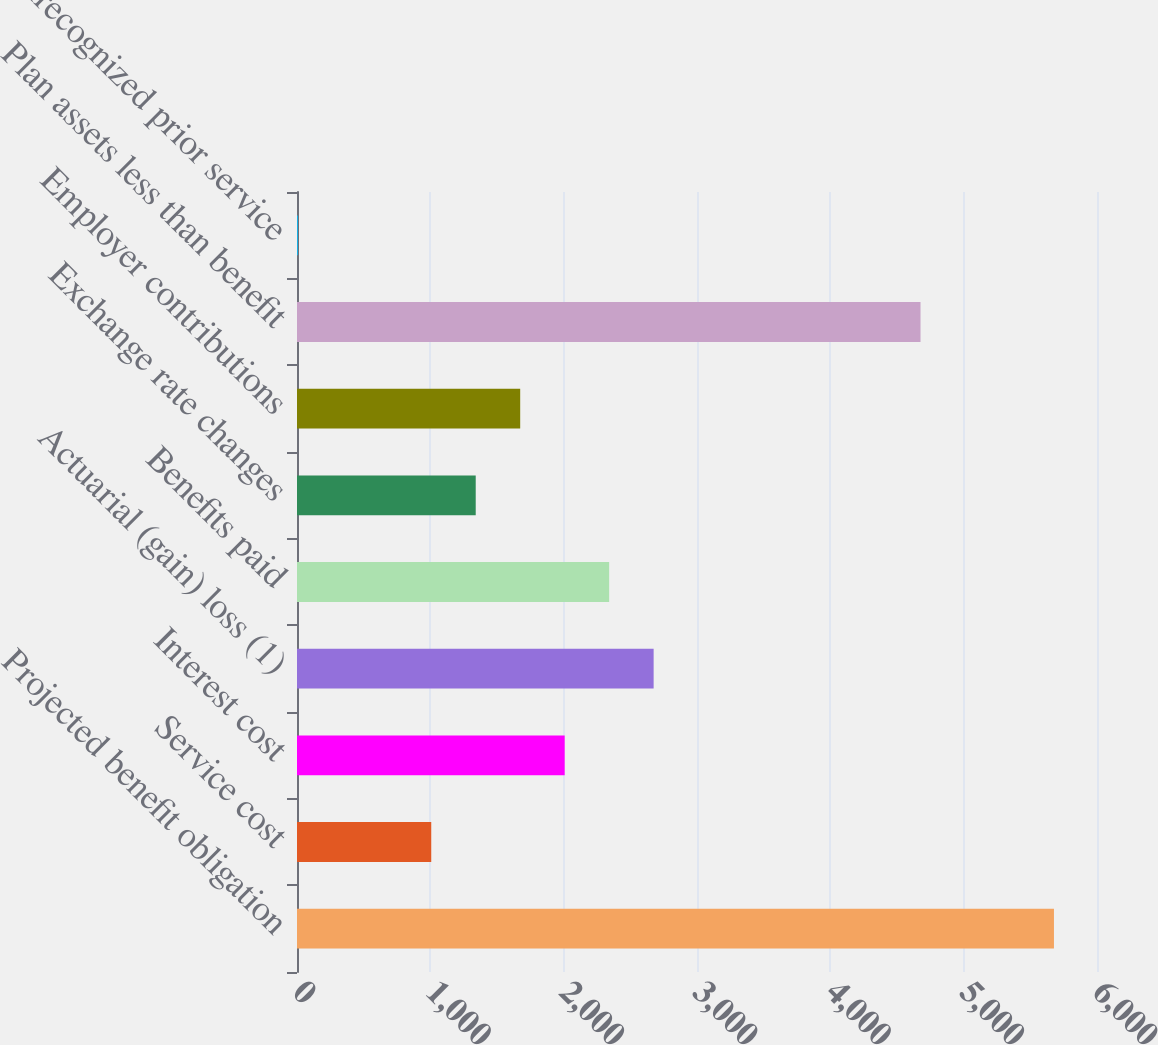Convert chart to OTSL. <chart><loc_0><loc_0><loc_500><loc_500><bar_chart><fcel>Projected benefit obligation<fcel>Service cost<fcel>Interest cost<fcel>Actuarial (gain) loss (1)<fcel>Benefits paid<fcel>Exchange rate changes<fcel>Employer contributions<fcel>Plan assets less than benefit<fcel>Unrecognized prior service<nl><fcel>5677.2<fcel>1006.8<fcel>2007.6<fcel>2674.8<fcel>2341.2<fcel>1340.4<fcel>1674<fcel>4676.4<fcel>6<nl></chart> 